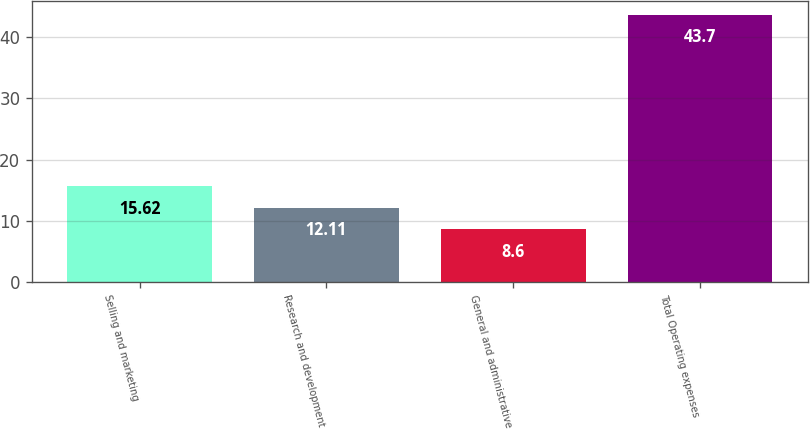Convert chart. <chart><loc_0><loc_0><loc_500><loc_500><bar_chart><fcel>Selling and marketing<fcel>Research and development<fcel>General and administrative<fcel>Total Operating expenses<nl><fcel>15.62<fcel>12.11<fcel>8.6<fcel>43.7<nl></chart> 